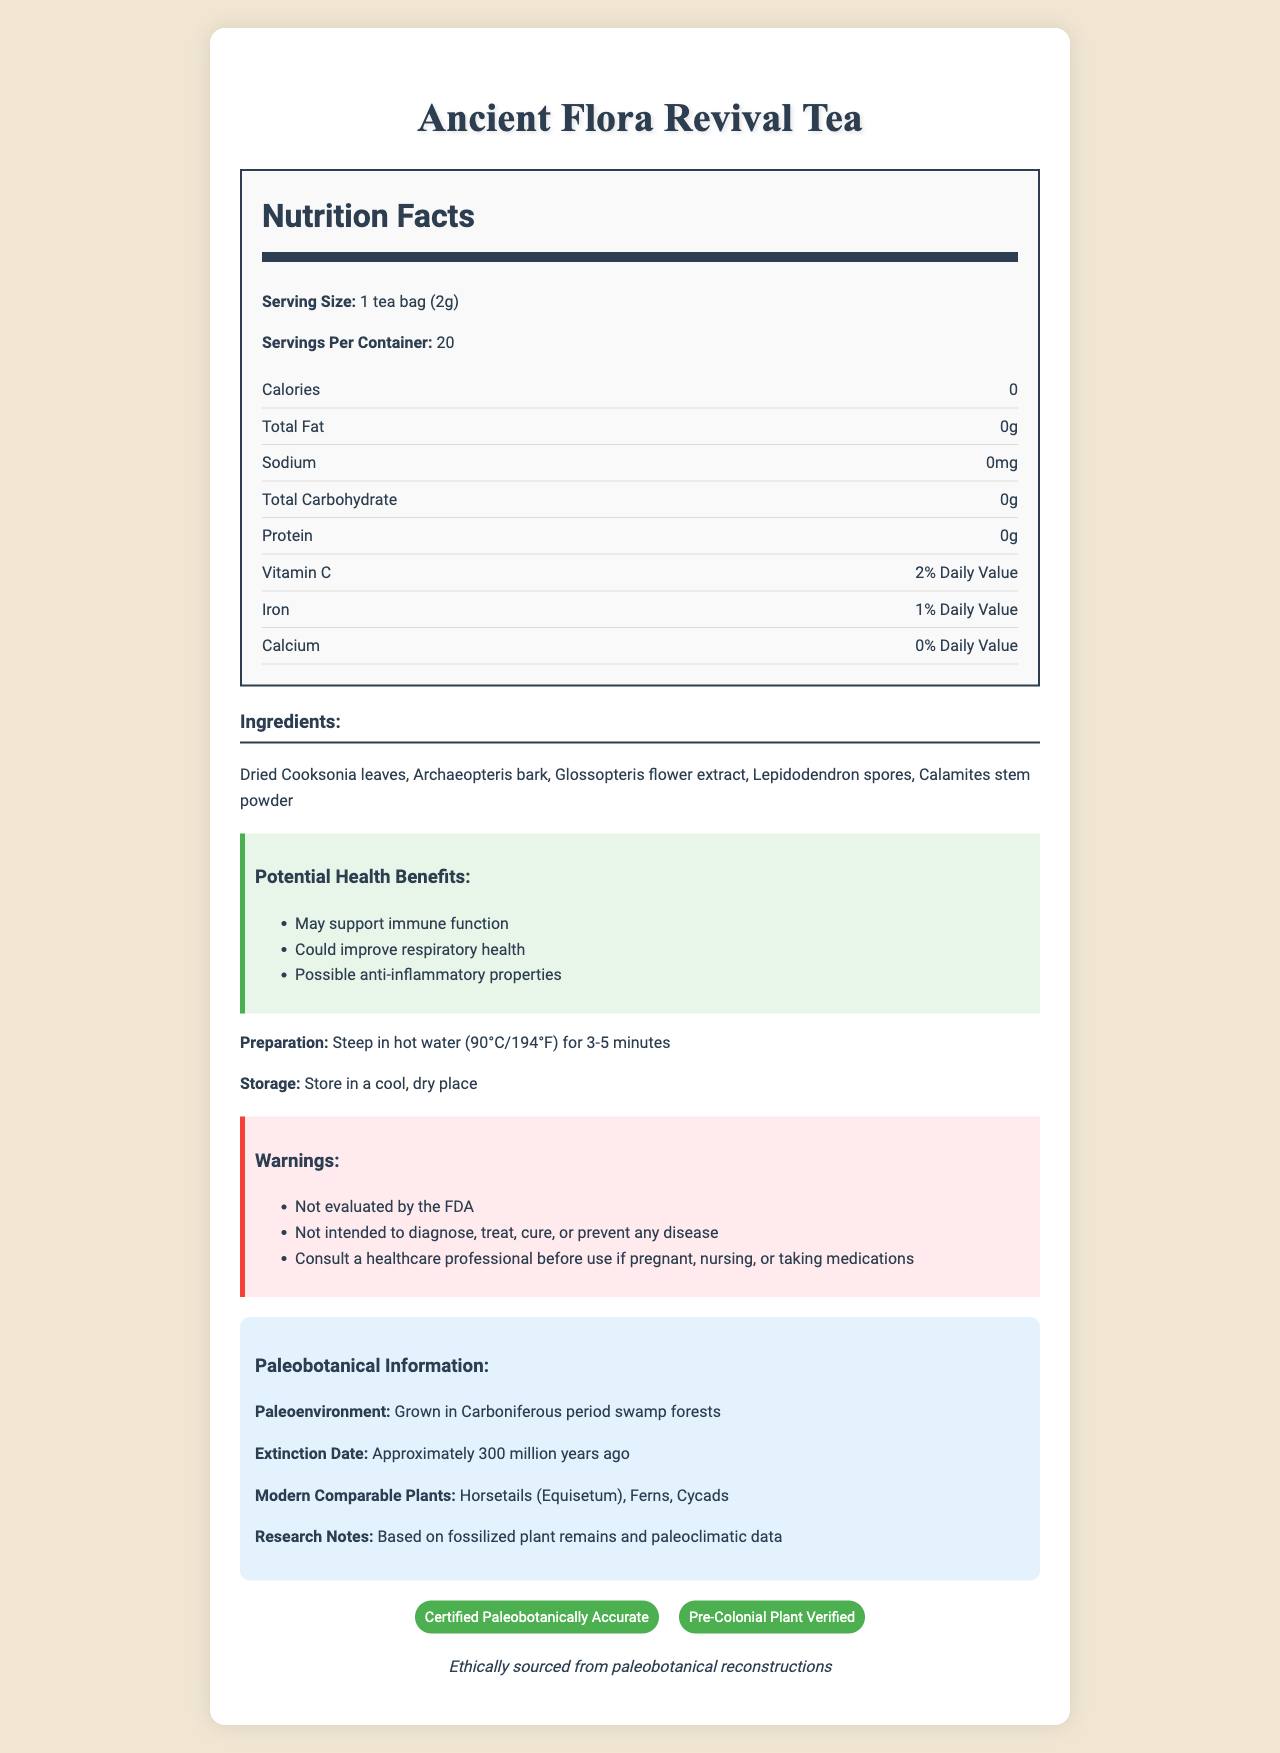what is the serving size of Ancient Flora Revival Tea? The serving size is clearly listed as "1 tea bag (2g)" near the top of the Nutrition Facts section.
Answer: 1 tea bag (2g) how many calories are in one serving? The document states that there are 0 calories per serving.
Answer: 0 name three ingredients in the tea The document lists the ingredients clearly and these three are the first in the list.
Answer: Dried Cooksonia leaves, Archaeopteris bark, Glossopteris flower extract what modern plants are comparable to the ones used in the tea? Under the Paleobotanical Information section, the document lists modern comparable plants.
Answer: Horsetails (Equisetum), Ferns, Cycads what are the potential health benefits of this tea? Under the Potential Health Benefits section, the document lists these three benefits.
Answer: Supports immune function, improves respiratory health, anti-inflammatory properties how many servings per container does the tea provide? A. 10 B. 15 C. 20 D. 25 The document states that there are 20 servings per container.
Answer: C. 20 what is the percentage of daily value for vitamin C in this tea? A. 0% B. 1% C. 2% D. 10% Under the nutrition label, the vitamin C content is listed as "2% Daily Value".
Answer: C. 2% is this product FDA evaluated? In the warnings section, it is stated that the product is "Not evaluated by the FDA".
Answer: No summarize the main idea of this document The document outlines the essential details about the tea, emphasizing its unique ancient ingredients, health benefits, and ethical sourcing.
Answer: The document provides detailed information about Ancient Flora Revival Tea, including its nutritional facts, ingredients, potential health benefits, preparation and storage instructions, warnings, paleobotanical background, and certifications. what is the exact amount of calcium provided in one serving of this tea? The document only provides the daily value percentage of calcium (0%), but it does not give the exact amount in milligrams or grams.
Answer: Cannot be determined 